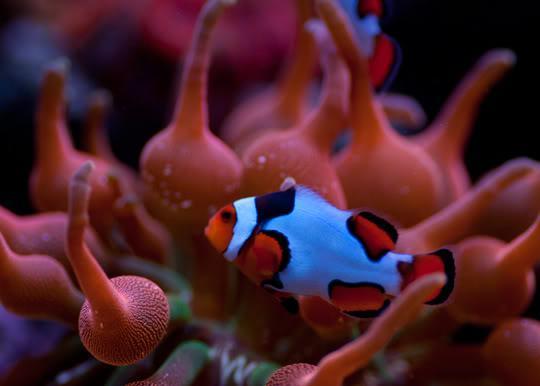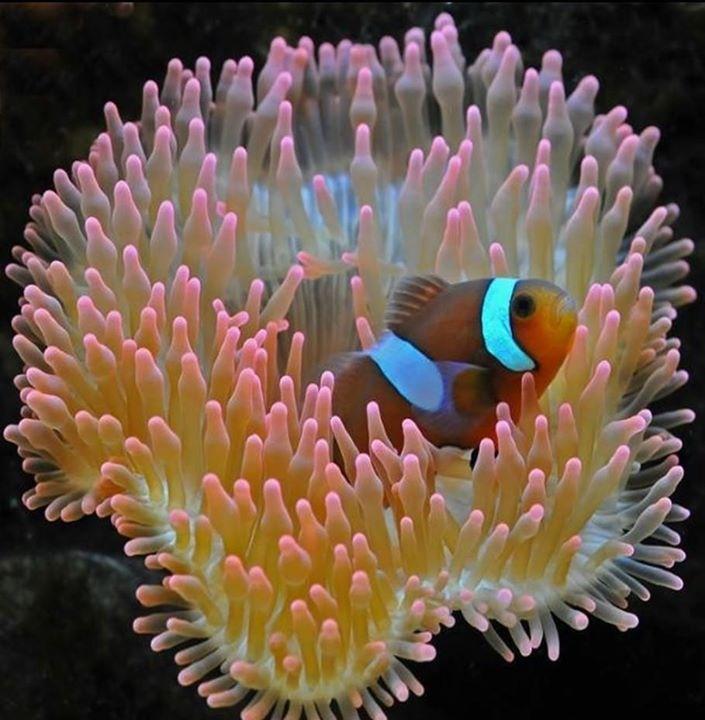The first image is the image on the left, the second image is the image on the right. Evaluate the accuracy of this statement regarding the images: "Left image shows an orange fish with one white stripe swimming among lavender-colored tendrils.". Is it true? Answer yes or no. No. The first image is the image on the left, the second image is the image on the right. Given the left and right images, does the statement "Exactly two fish are seen hiding in the sea plant." hold true? Answer yes or no. Yes. 